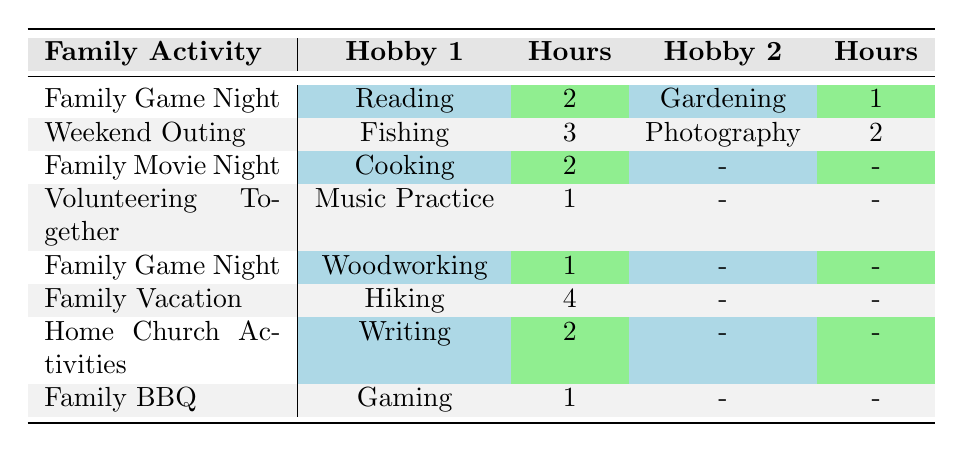What is the total time spent on hobbies during Family Game Night? There are two hobbies listed for Family Game Night: Reading (2 hours) and Woodworking (1 hour). Adding these hours gives 2 + 1 = 3 hours spent on hobbies during Family Game Night.
Answer: 3 hours Which family activity allows for the most time spent on a single hobby? The Family Vacation activity allows for the most time spent on a single hobby, which is Hiking for 4 hours.
Answer: Family Vacation Is there a family activity where no hobbies are listed? In the table, Family Movie Night and Volunteering Together both have one hobby listed or none. However, Family Movie Night shows Cooking (2 hours), while Family Movie Night does not have an entry for a second hobby. Therefore, the answer is no.
Answer: No What is the average time spent on hobbies for Family BBQ and Home Church Activities combined? The Family BBQ has 1 hour for Gaming, and Home Church Activities has 2 hours for Writing. To find the average, first sum the hours: 1 + 2 = 3 hours. Then divide by the number of activities (2): 3 / 2 = 1.5 hours.
Answer: 1.5 hours Which hobby has the least time spent according to the table? The least time spent on a hobby is 1 hour for both Gardening and Woodworking; both activities are the lowest in the table.
Answer: 1 hour How many hobbies are listed for Family Vacation? Family Vacation has only one hobby listed, which is Hiking with 4 hours spent on it. There are no additional hobbies mentioned under this activity.
Answer: 1 hobby Is Cooking the only hobby related to Family Movie Night? Yes, Family Movie Night has Cooking listed for 2 hours and does not have another hobby mention. Thus, Cooking is indeed the only hobby for that activity.
Answer: Yes Which family activity contributes most to the overall total hours spent? To find the family activity that contributes most to total hours spent, we sum the hours for each family activity: Family Game Night (3), Weekend Outing (5), Family Movie Night (2), Volunteering Together (1), Family Vacation (4), Home Church Activities (2), and Family BBQ (1). The highest total is from Weekend Outing with 5 hours.
Answer: Weekend Outing What percentage of time is spent on hobbies during Family Game Night compared to Family Vacation? Family Game Night has a total of 3 hours for hobbies, while Family Vacation has a total of 4 hours. To find the percentage: (3 / (3 + 4)) * 100 = (3 / 7) * 100 ≈ 42.86%.
Answer: Approximately 42.86% 